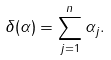Convert formula to latex. <formula><loc_0><loc_0><loc_500><loc_500>\delta ( \alpha ) = \sum _ { j = 1 } ^ { n } \alpha _ { j } .</formula> 